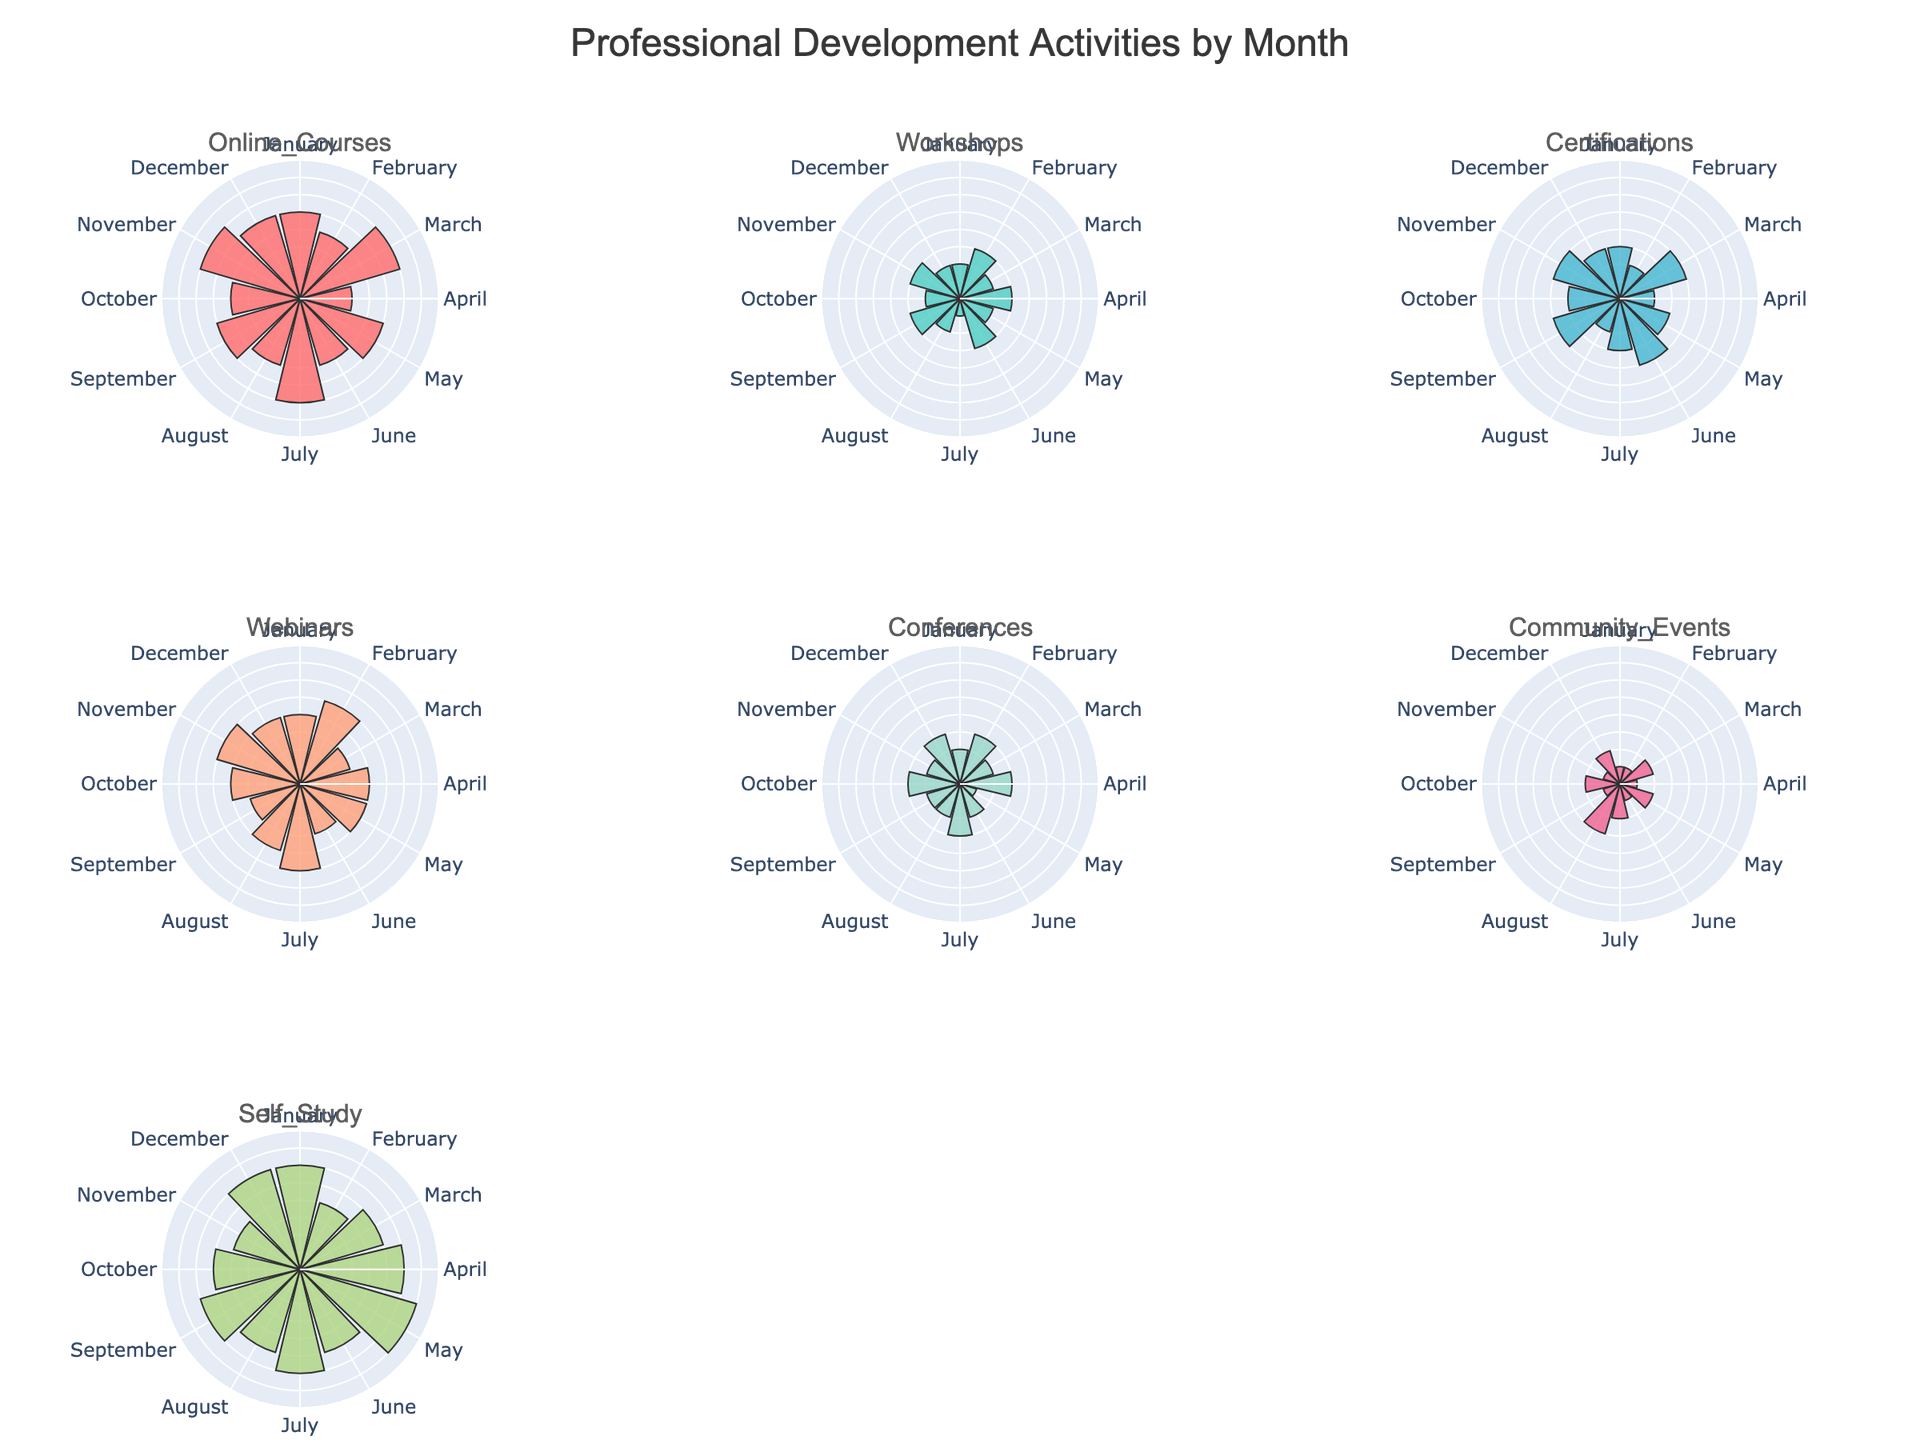What's the title of the plot? The title is often at the top of the plot and explicitly labeled. In this case, it is provided by the code as "Professional Development Activities by Month."
Answer: Professional Development Activities by Month How many months are represented in each rose chart? Each subplot represents data collected across all months, which can be counted from "January" to "December." This gives us 12 months.
Answer: 12 What activity has the highest frequency in January? Look at the segment for January in each subplot. The segment with the longest radius corresponds to the highest frequency. For January, the longest radius is in the Self-Study subplot, indicating 6 occurrences.
Answer: Self-Study In which month were there equal frequencies for Workshops and Webinars? Compare each month's segment across the Workshops and Webinars subplots. For February and October, both Workshops and Webinars have the same frequency of 3 and 4, respectively.
Answer: February and October Which activity shows the most significant fluctuation in terms of monthly frequency? By visually comparing the varying lengths of segments for each activity across different months, it seems Online Courses and Self-Study have noticeable fluctuations. However, changes in Self-Study are the most significant, varying from 4 to 7.
Answer: Self-Study What's the combined frequency of online courses and certifications in March? For March, combine the frequencies of Online Courses (6) and Certifications (4) segments. Thus, the combined frequency is 6 + 4 = 10.
Answer: 10 Which activity has the most consistent frequency across all months? Look at each activity's subplot to identify which one has relatively equal segment lengths across all months. Workshops have more consistent segment lengths compared to others.
Answer: Workshops What is the total frequency of Community Events from January to December? Add the frequencies for Community Events from January to December, 1 + 1 + 2 + 1 + 2 + 1 + 2 + 3 + 1 + 2 + 1 + 2, making the total 19.
Answer: 19 Which month has the highest frequency of Conferences? Identify the longest segment in the Conferences subplot. November has the longest segment with a frequency of 5.
Answer: November 